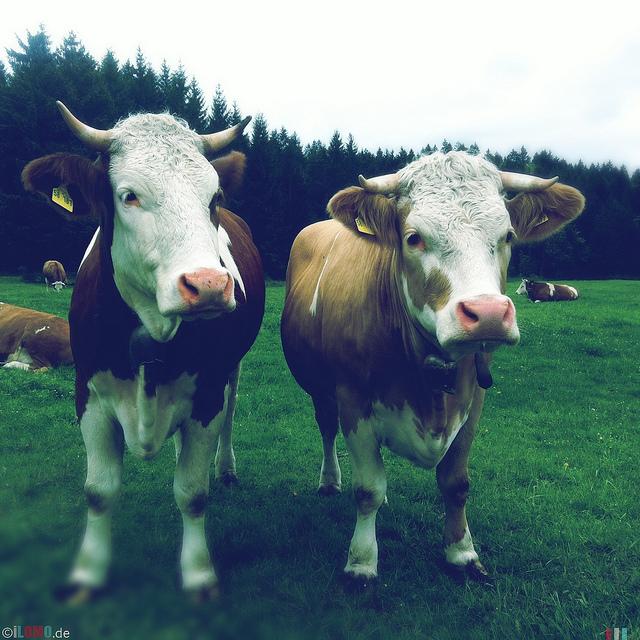Are the cows in a barn?
Quick response, please. No. Are these cows or bulls?
Quick response, please. Bulls. How many cows are lying down in the background?
Keep it brief. 2. 